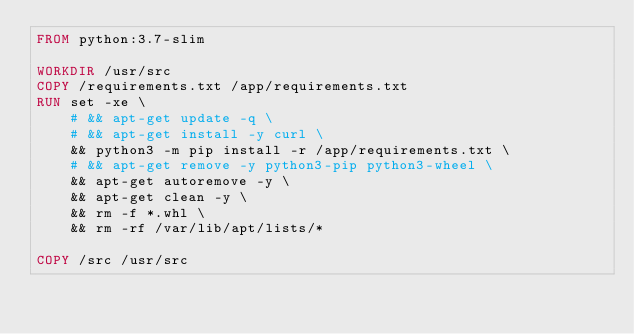Convert code to text. <code><loc_0><loc_0><loc_500><loc_500><_Dockerfile_>FROM python:3.7-slim

WORKDIR /usr/src
COPY /requirements.txt /app/requirements.txt
RUN set -xe \
    # && apt-get update -q \
    # && apt-get install -y curl \
    && python3 -m pip install -r /app/requirements.txt \
    # && apt-get remove -y python3-pip python3-wheel \
    && apt-get autoremove -y \
    && apt-get clean -y \
    && rm -f *.whl \
    && rm -rf /var/lib/apt/lists/*

COPY /src /usr/src</code> 